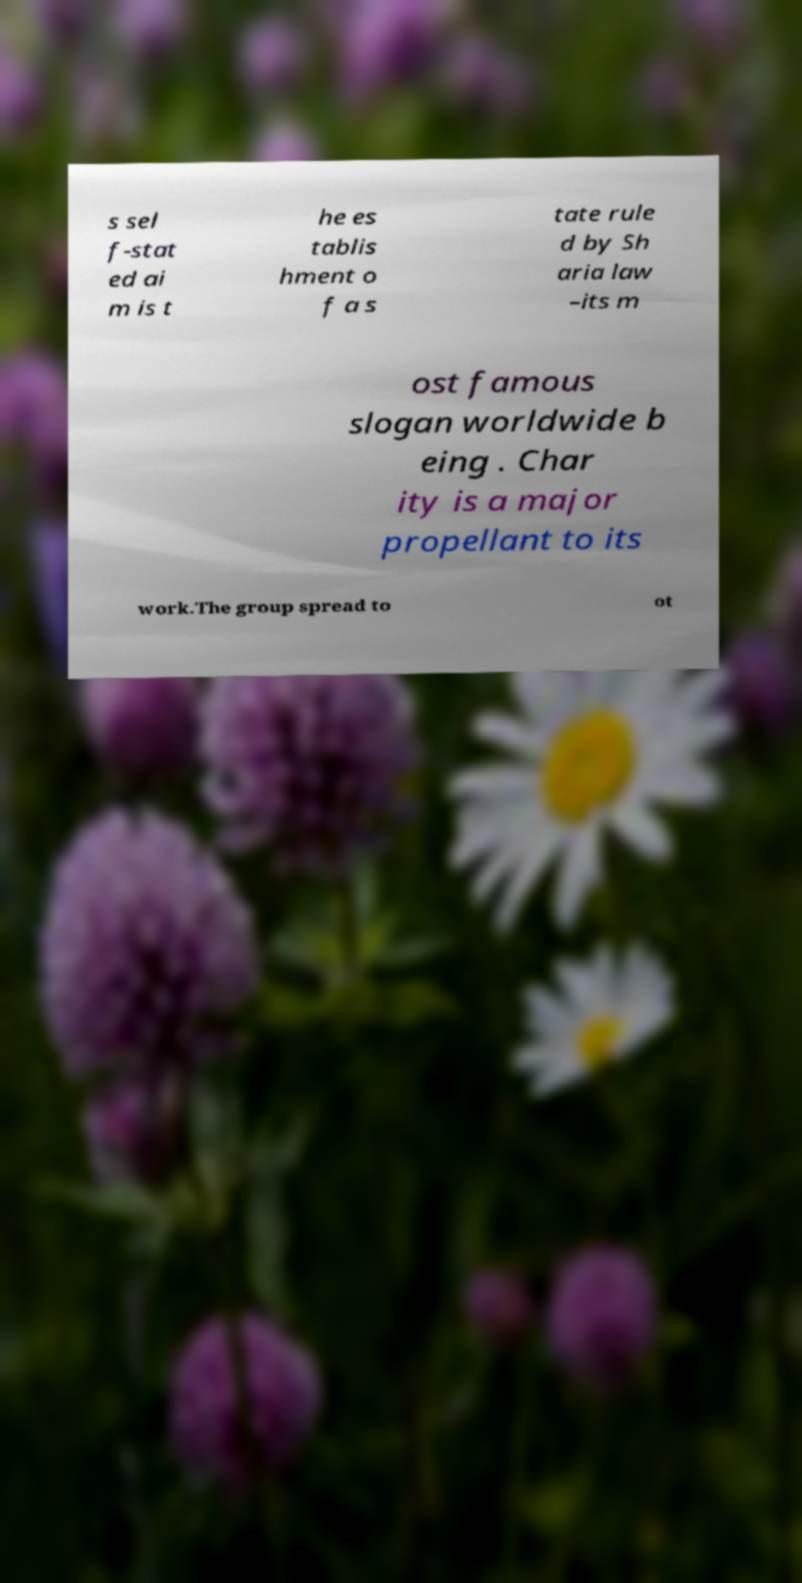For documentation purposes, I need the text within this image transcribed. Could you provide that? s sel f-stat ed ai m is t he es tablis hment o f a s tate rule d by Sh aria law –its m ost famous slogan worldwide b eing . Char ity is a major propellant to its work.The group spread to ot 